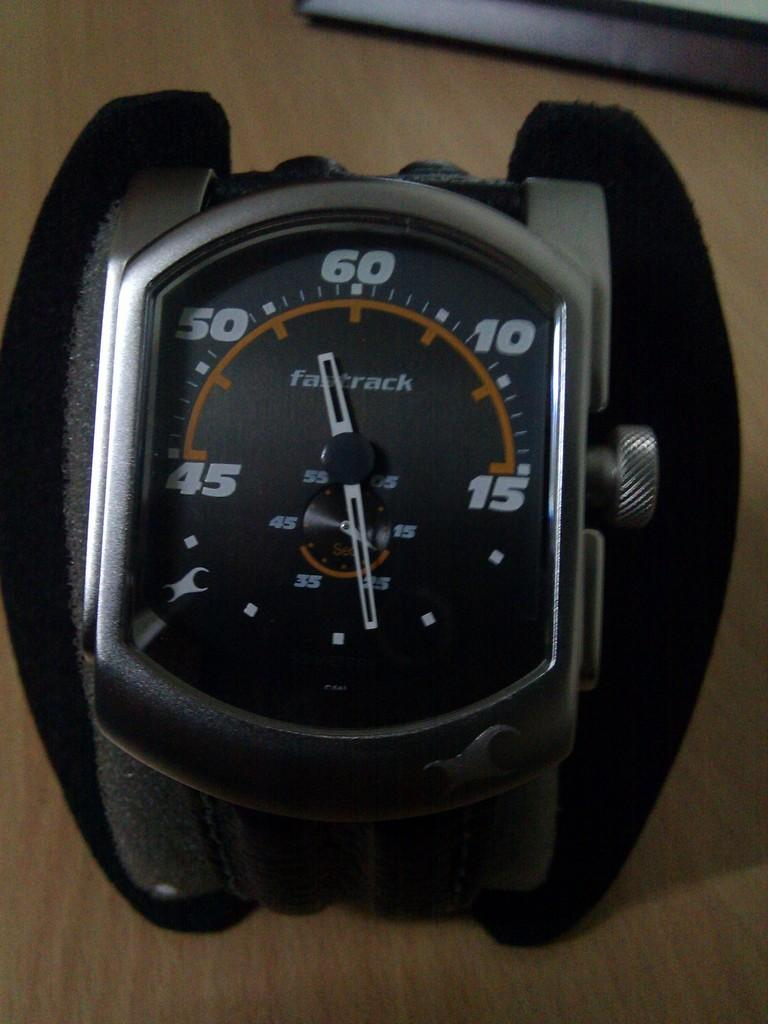<image>
Share a concise interpretation of the image provided. A wrist watch that says fasttrack on the face of it. 